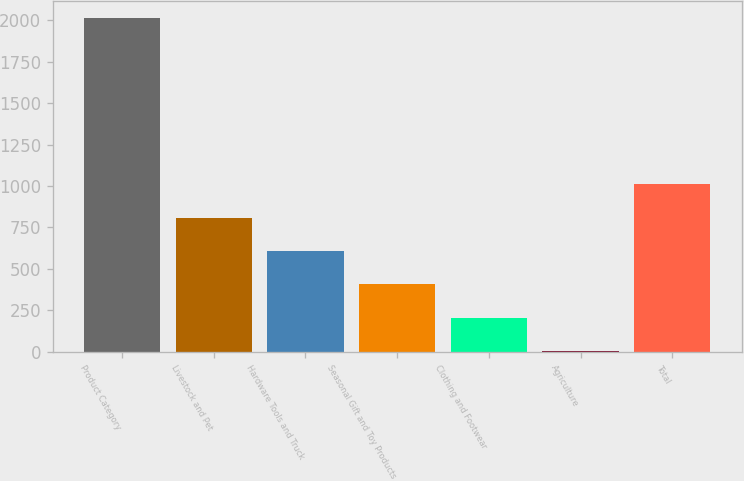<chart> <loc_0><loc_0><loc_500><loc_500><bar_chart><fcel>Product Category<fcel>Livestock and Pet<fcel>Hardware Tools and Truck<fcel>Seasonal Gift and Toy Products<fcel>Clothing and Footwear<fcel>Agriculture<fcel>Total<nl><fcel>2015<fcel>809<fcel>608<fcel>407<fcel>206<fcel>5<fcel>1010<nl></chart> 